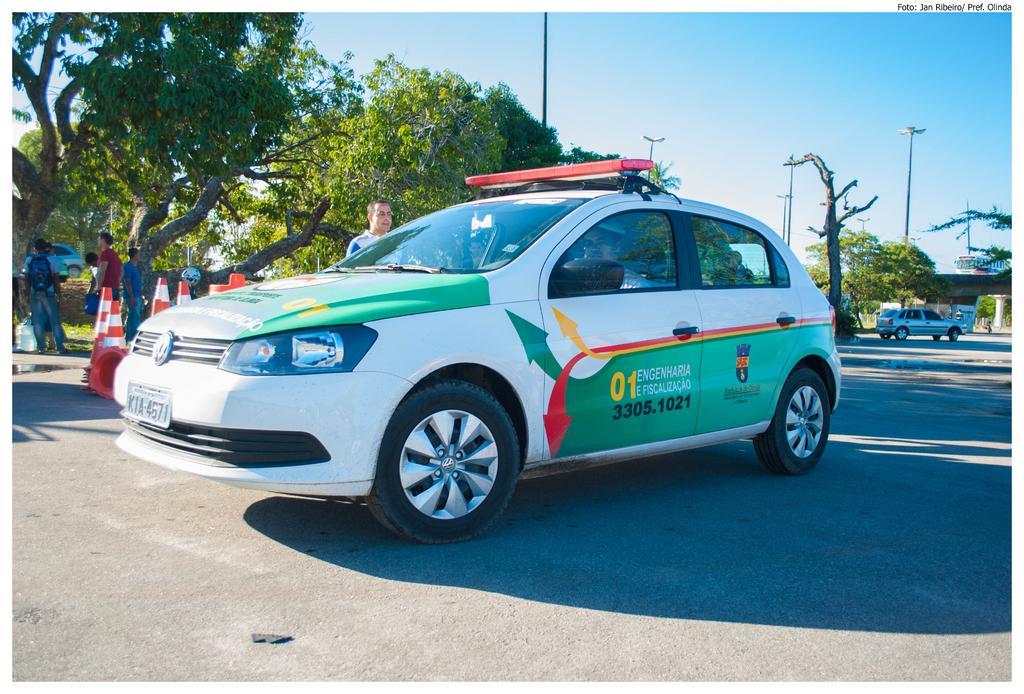Can you describe this image briefly? In front of the image there is a car, behind the car there are traffic cones, a few people and trees. In the background of the image there are cars on the roads, lamp posts, bus on the bridge. 